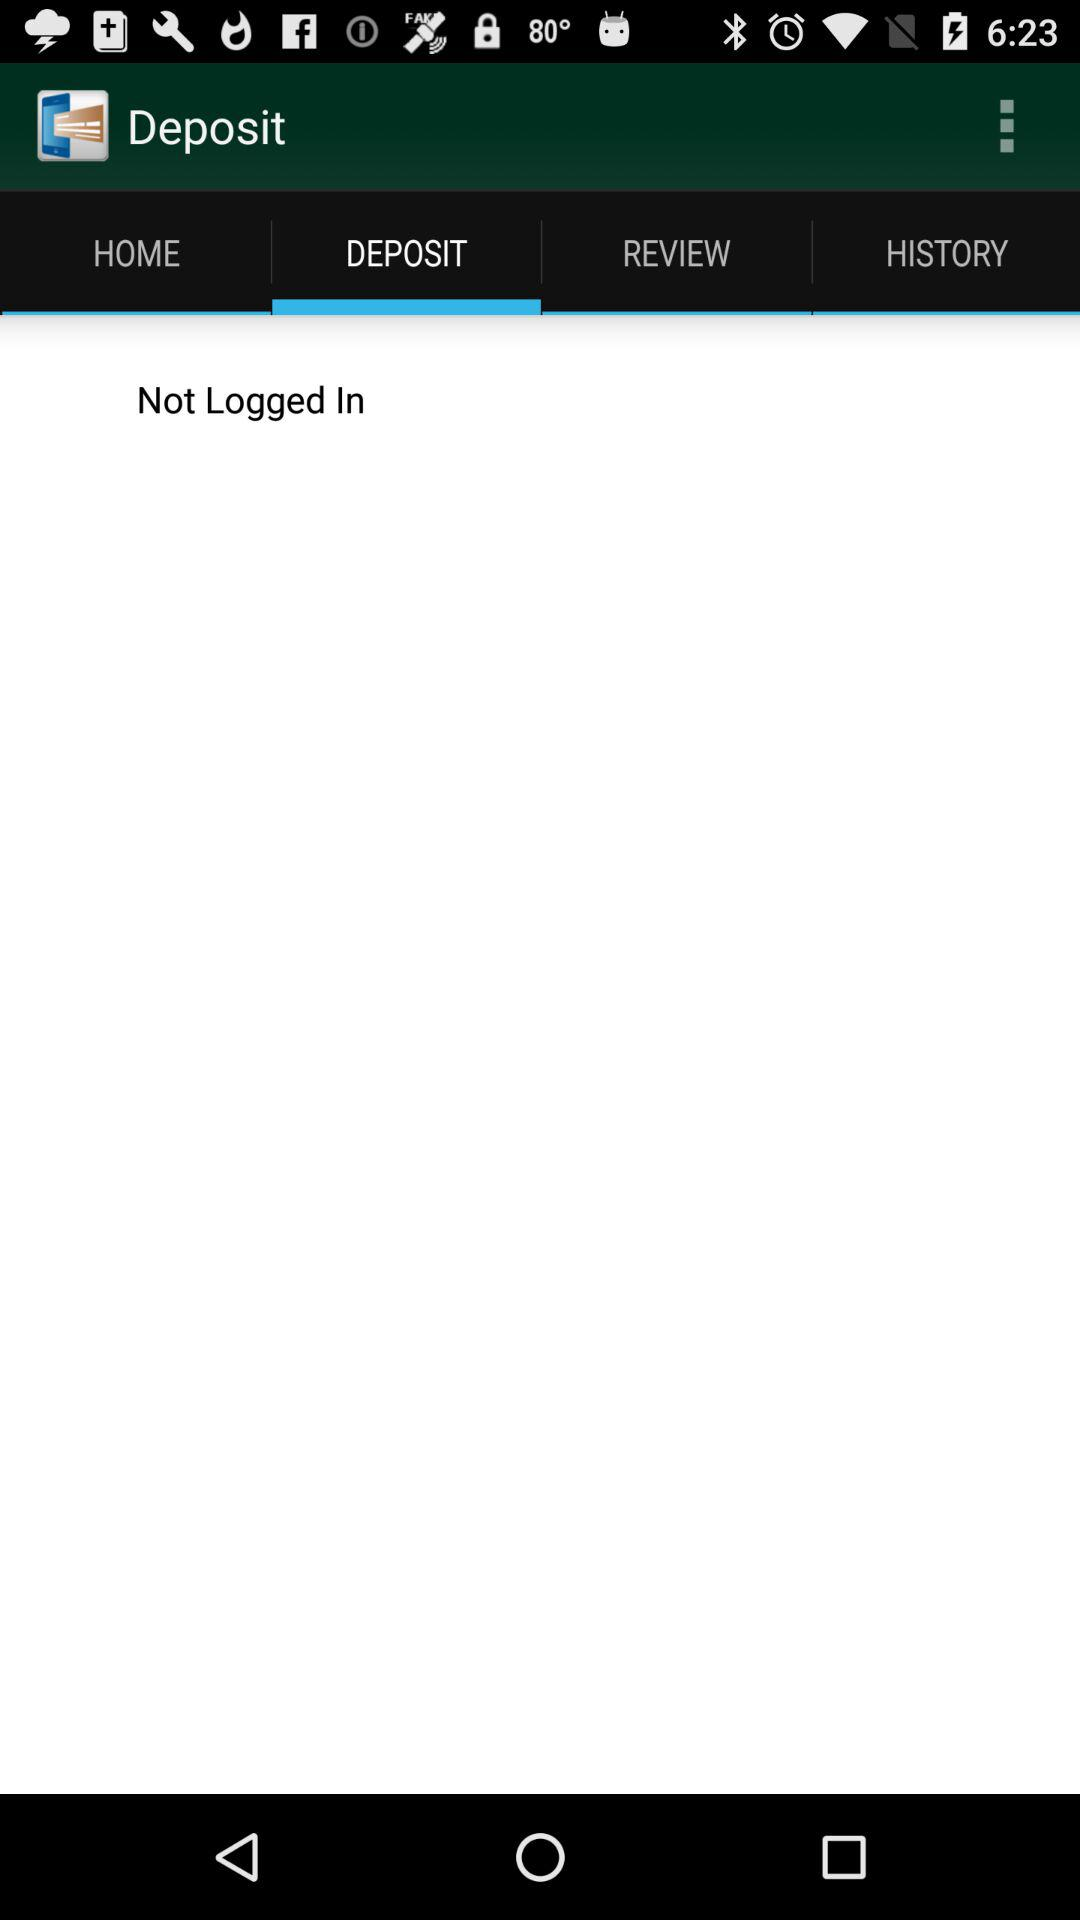Which tab is selected? The selected tab is "DEPOSIT". 